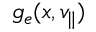<formula> <loc_0><loc_0><loc_500><loc_500>g _ { e } ( x , v _ { \| } )</formula> 